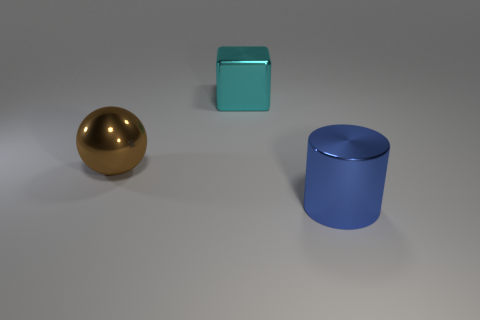Add 3 tiny purple things. How many objects exist? 6 Add 3 big brown shiny objects. How many big brown shiny objects exist? 4 Subtract 0 blue balls. How many objects are left? 3 Subtract all balls. How many objects are left? 2 Subtract all green spheres. Subtract all cyan cylinders. How many spheres are left? 1 Subtract all small yellow blocks. Subtract all shiny objects. How many objects are left? 0 Add 2 cyan blocks. How many cyan blocks are left? 3 